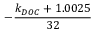Convert formula to latex. <formula><loc_0><loc_0><loc_500><loc_500>- \frac { k _ { D O C } + 1 . 0 0 2 5 } { 3 2 }</formula> 